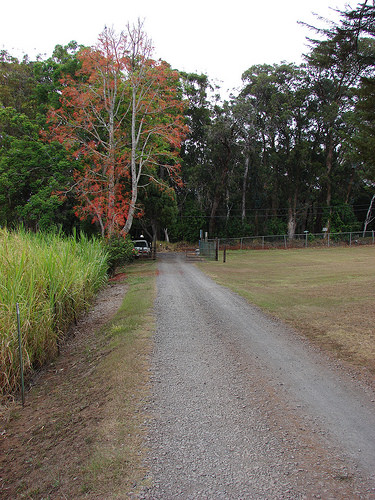<image>
Can you confirm if the trees is on the road? No. The trees is not positioned on the road. They may be near each other, but the trees is not supported by or resting on top of the road. 